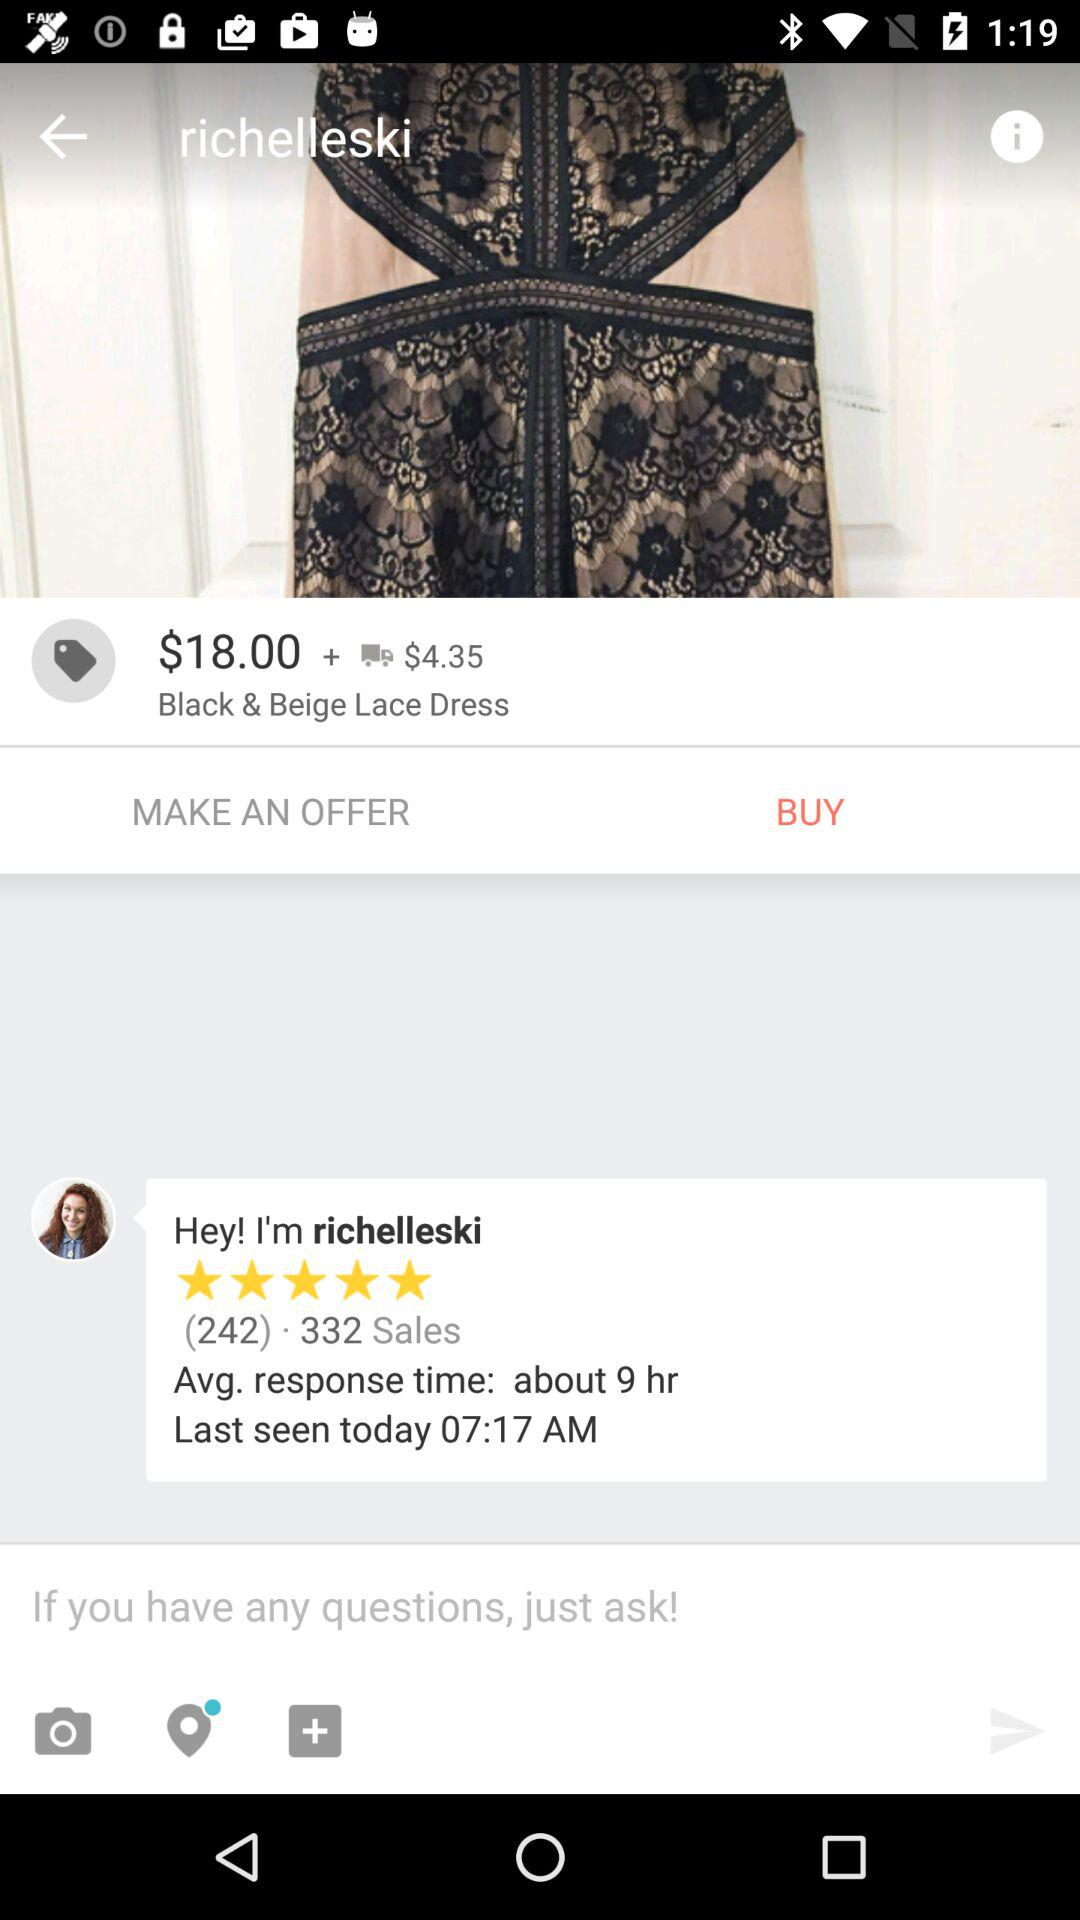What is the price of the "Black & Beige Lace Dress"? The price of the "Black & Beige Lace Dress" is $18.00. 